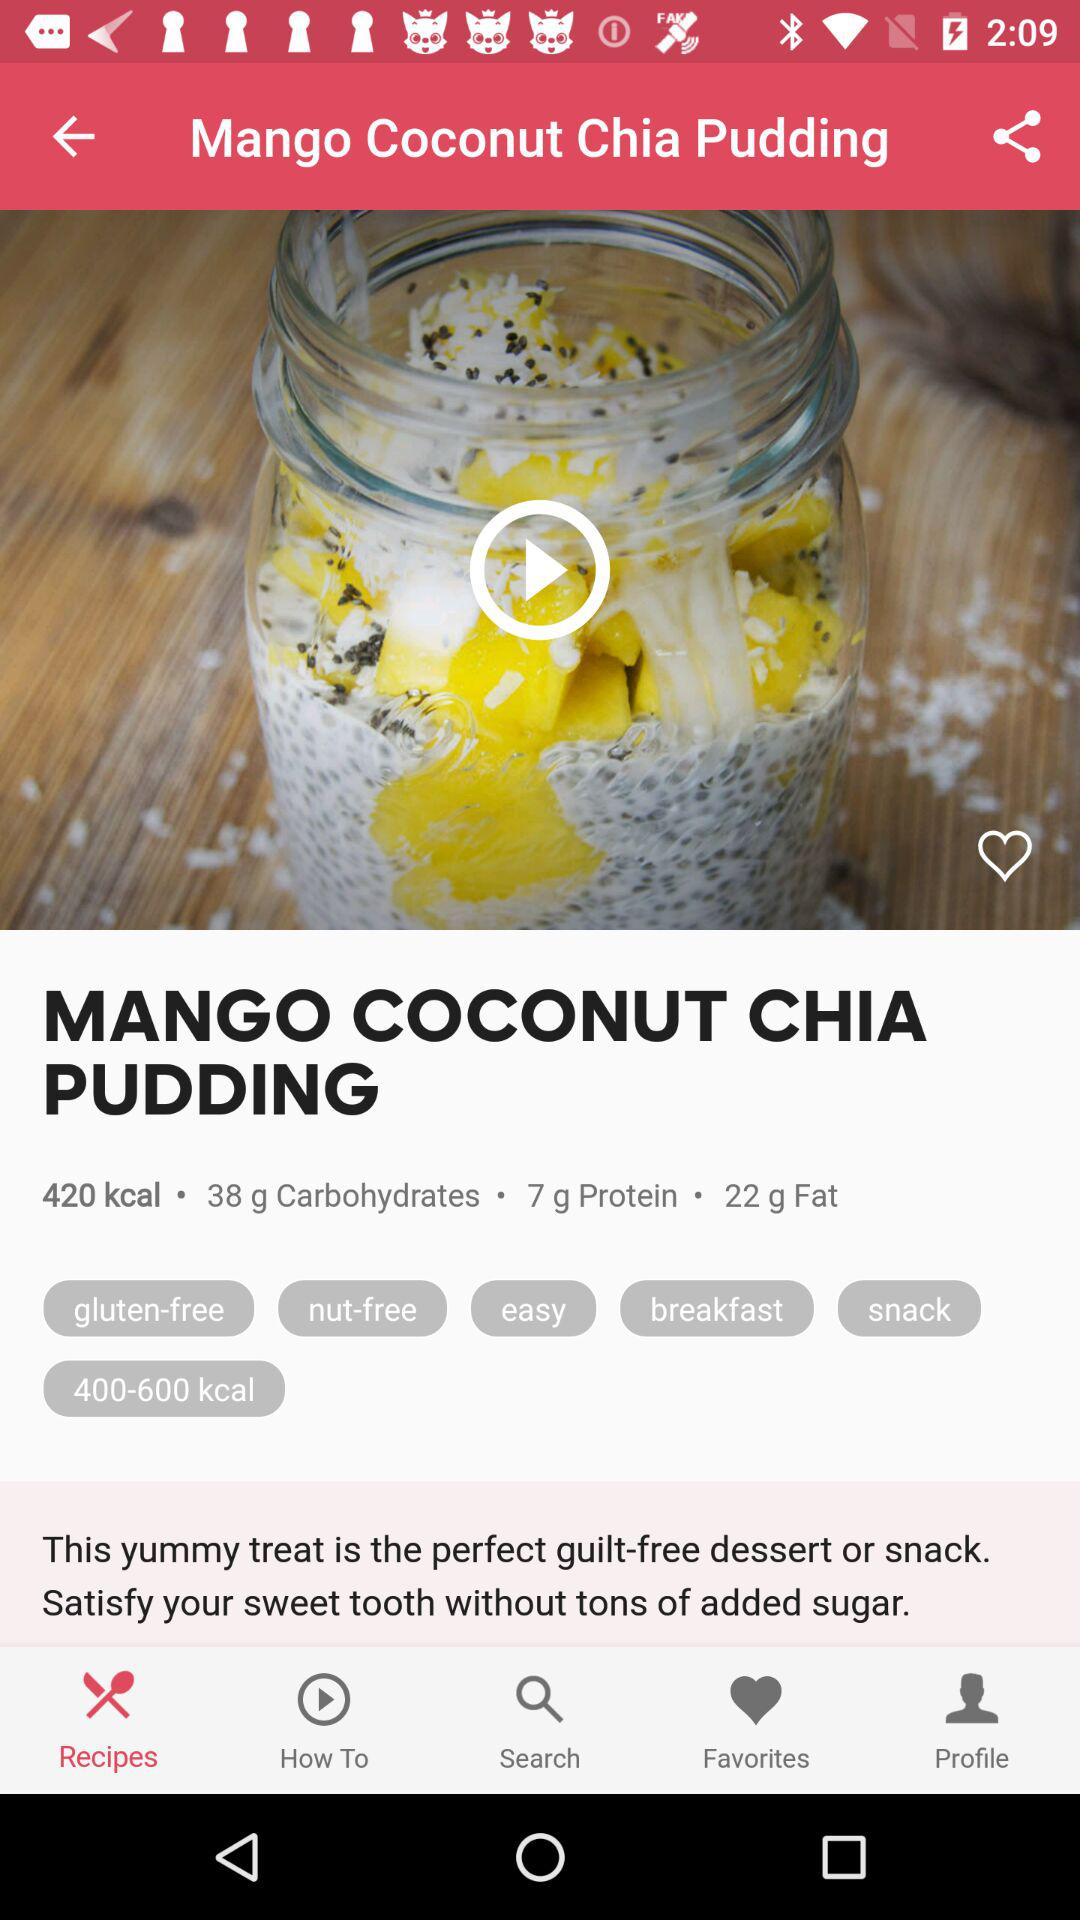Could this pudding be a good breakfast option? Certainly! With 7 grams of protein and 22 grams of fat, mostly from healthy sources like coconut and chia seeds, this pudding provides sustained energy. Its nutritional profile makes it suitable for a breakfast that can keep you full and satisfied throughout the morning. 